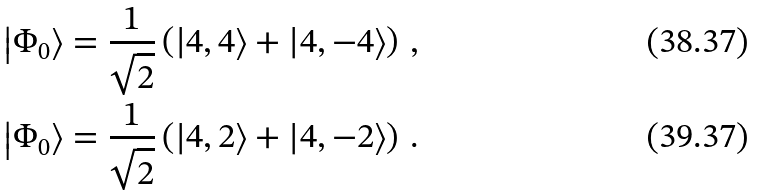<formula> <loc_0><loc_0><loc_500><loc_500>\left | \Phi _ { 0 } \right > & = \frac { 1 } { \sqrt { 2 } } \left ( \left | 4 , 4 \right > + \left | 4 , - 4 \right > \right ) \, , \\ \left | \Phi _ { 0 } \right > & = \frac { 1 } { \sqrt { 2 } } \left ( \left | 4 , 2 \right > + \left | 4 , - 2 \right > \right ) \, .</formula> 